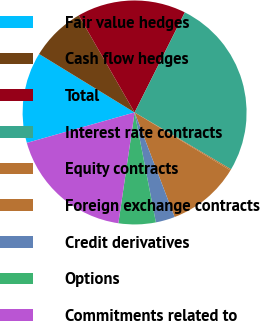<chart> <loc_0><loc_0><loc_500><loc_500><pie_chart><fcel>Fair value hedges<fcel>Cash flow hedges<fcel>Total<fcel>Interest rate contracts<fcel>Equity contracts<fcel>Foreign exchange contracts<fcel>Credit derivatives<fcel>Options<fcel>Commitments related to<nl><fcel>13.13%<fcel>7.95%<fcel>15.72%<fcel>26.08%<fcel>0.18%<fcel>10.54%<fcel>2.77%<fcel>5.36%<fcel>18.31%<nl></chart> 